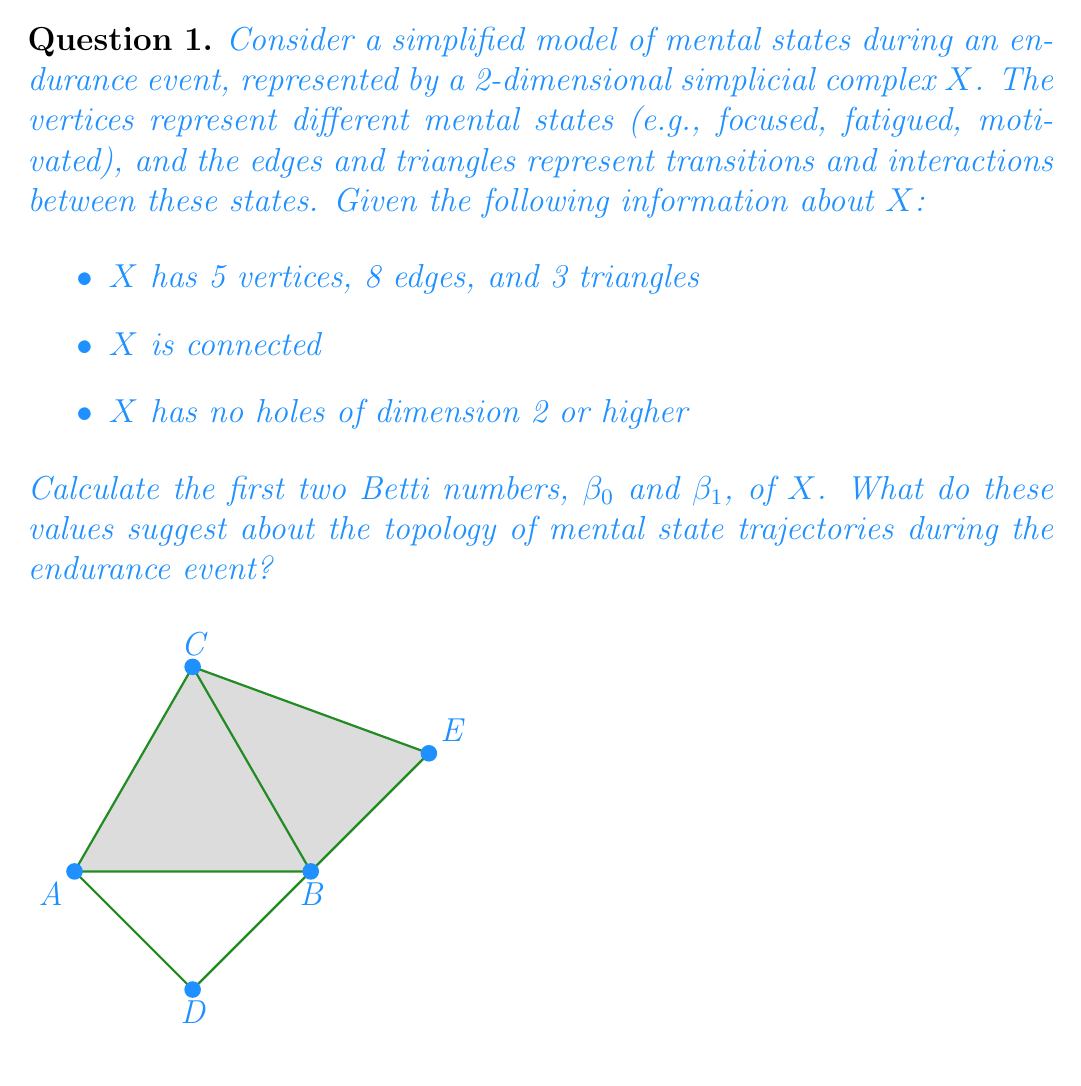Give your solution to this math problem. To calculate the Betti numbers and interpret their meaning, we'll follow these steps:

1) First, let's recall the definition of Betti numbers:
   - $\beta_0$ is the number of connected components
   - $\beta_1$ is the number of 1-dimensional holes (loops)
   - $\beta_2$ is the number of 2-dimensional holes (voids)

2) We're given that $X$ is connected, so $\beta_0 = 1$.

3) To find $\beta_1$, we can use the Euler characteristic formula:
   $$\chi(X) = V - E + F = \beta_0 - \beta_1 + \beta_2$$
   where $V$ is the number of vertices, $E$ is the number of edges, and $F$ is the number of faces (triangles).

4) We're given that $V = 5$, $E = 8$, and $F = 3$. Substituting these values:
   $$\chi(X) = 5 - 8 + 3 = 0$$

5) We know $\beta_0 = 1$ and $\beta_2 = 0$ (no holes of dimension 2 or higher). Substituting into the Euler characteristic equation:
   $$0 = 1 - \beta_1 + 0$$
   $$\beta_1 = 1$$

6) Interpretation:
   - $\beta_0 = 1$ indicates that the mental state space is connected, suggesting that all mental states are reachable from one another during the endurance event.
   - $\beta_1 = 1$ suggests the presence of one loop in the mental state trajectories. This could represent a cyclic pattern in mental states during the event, such as alternating between motivation and fatigue.

These Betti numbers provide insights into the topological structure of mental state transitions during endurance events, which could be valuable for understanding patterns in mental resilience and performance.
Answer: $\beta_0 = 1$, $\beta_1 = 1$ 